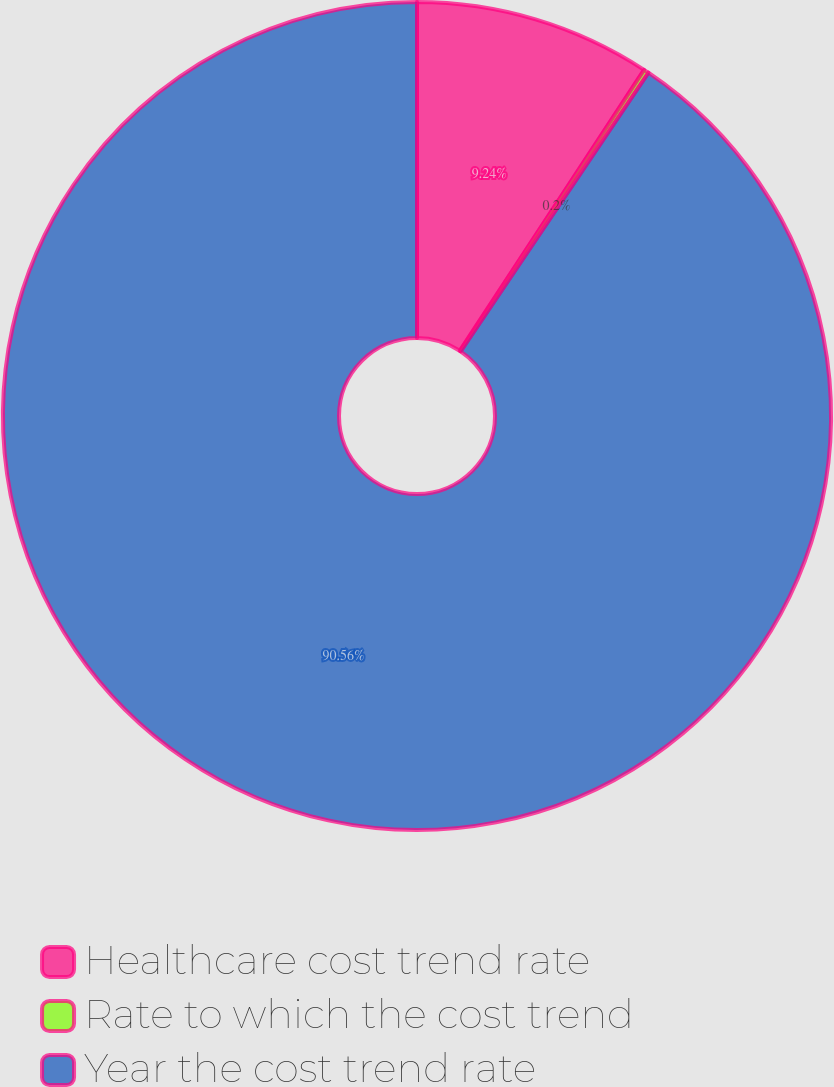<chart> <loc_0><loc_0><loc_500><loc_500><pie_chart><fcel>Healthcare cost trend rate<fcel>Rate to which the cost trend<fcel>Year the cost trend rate<nl><fcel>9.24%<fcel>0.2%<fcel>90.56%<nl></chart> 